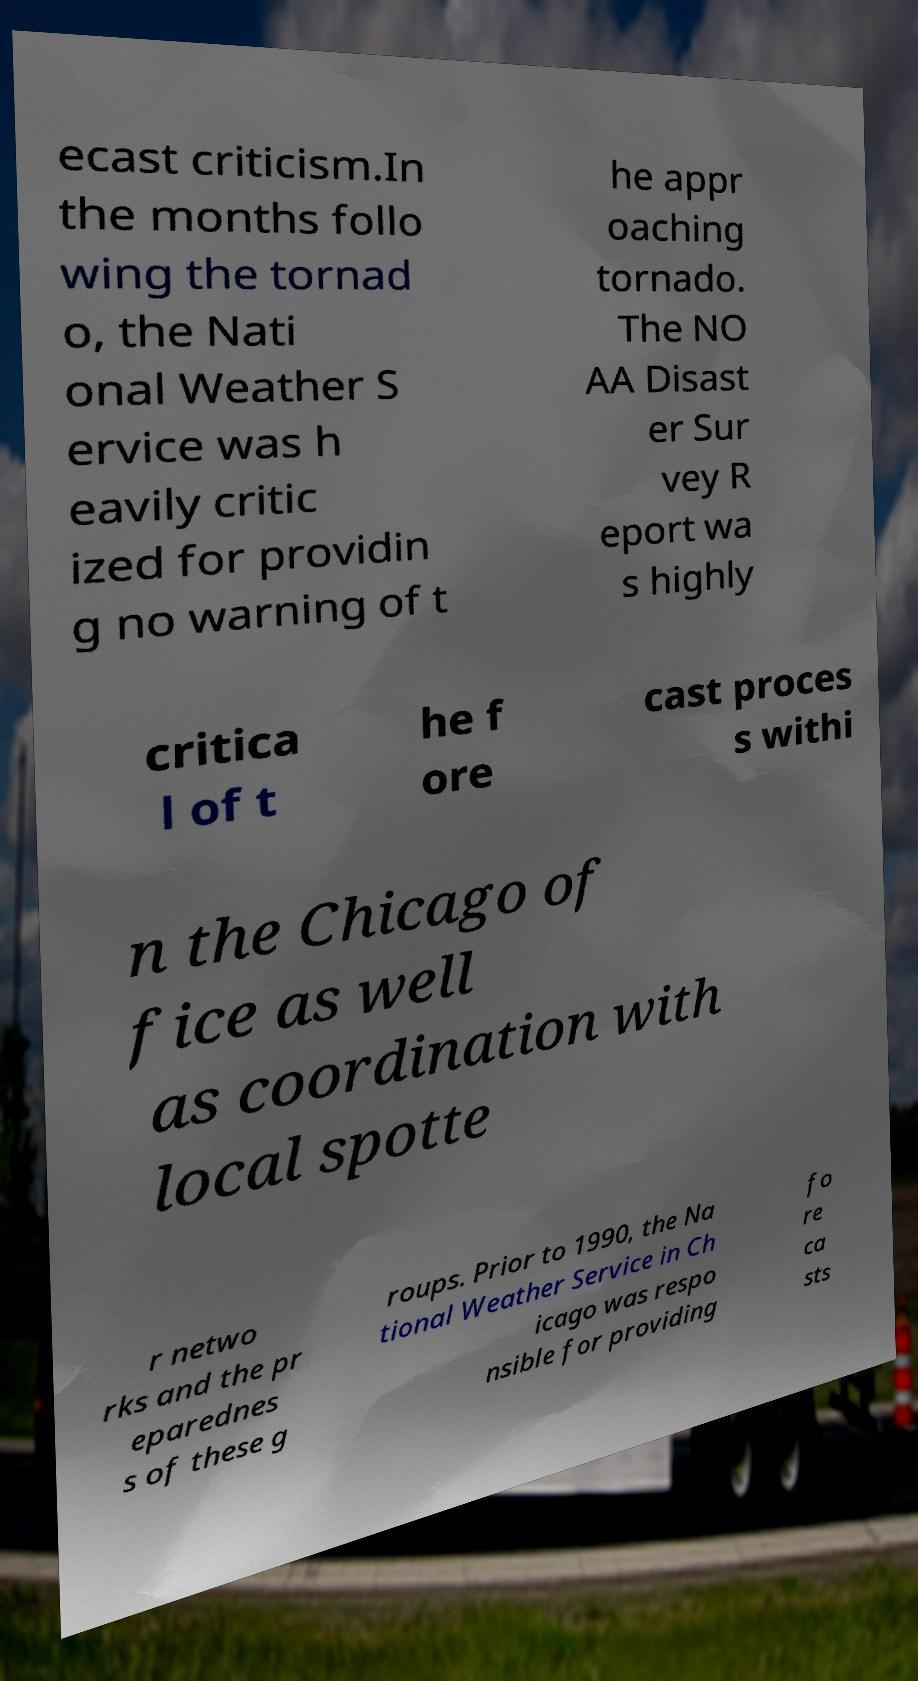I need the written content from this picture converted into text. Can you do that? ecast criticism.In the months follo wing the tornad o, the Nati onal Weather S ervice was h eavily critic ized for providin g no warning of t he appr oaching tornado. The NO AA Disast er Sur vey R eport wa s highly critica l of t he f ore cast proces s withi n the Chicago of fice as well as coordination with local spotte r netwo rks and the pr eparednes s of these g roups. Prior to 1990, the Na tional Weather Service in Ch icago was respo nsible for providing fo re ca sts 